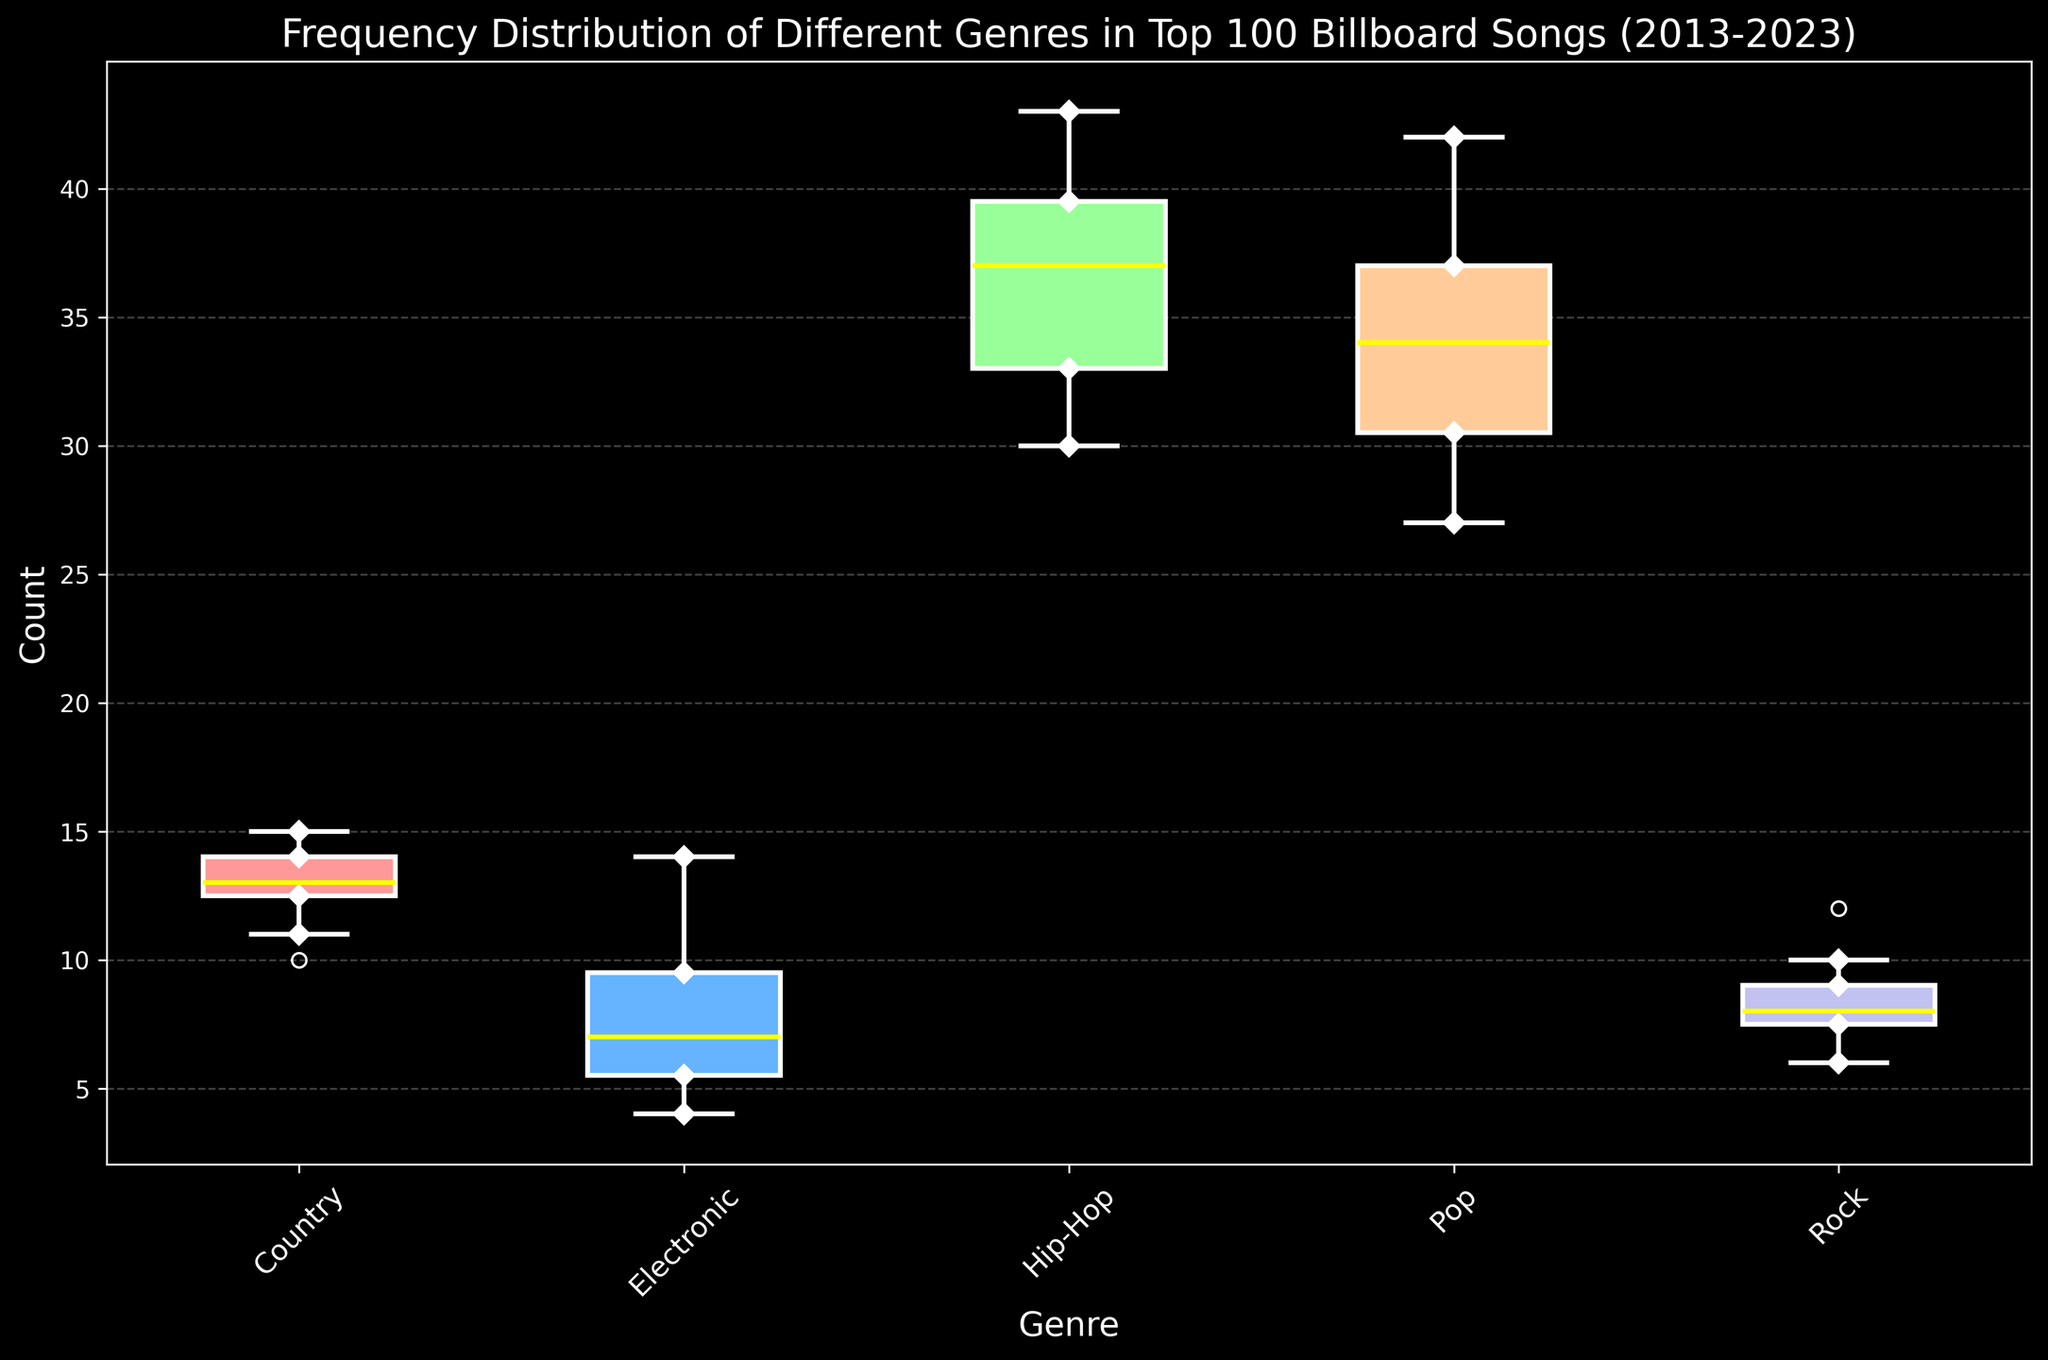What's the median count for Pop music? From the box plot, locate the median line within the Pop genre's box. The yellow line represents the median value.
Answer: 34 Which genre has the highest maximum count? Examine the top whisker of all box plots to determine which genre has the highest value. Hip-Hop genre has the highest whiskers indicating the highest maximum count.
Answer: Hip-Hop What is the interquartile range (IQR) for Country music? The IQR is calculated as the difference between the upper quartile (Q3) and the lower quartile (Q1). From the box plot, locate these values for Country music and subtract the lower quartile from the upper quartile.
Answer: 4 How does the variability in counts for Electronic music compare to Rock music? Assess the height of the boxes and thus the range of the counts within each box plot. The box for Electronic is taller than Rock, indicating greater variability.
Answer: Greater for Electronic Which genre has the smallest range? Determine the genre with the shortest distance between its whiskers. Rock music has the smallest range, visible through the shortest whiskers.
Answer: Rock Are the counts for Hip-Hop consistently increasing over the years? Examining the height and consistency of the median line in the Hip-Hop box plot over the years confirms a consistent increase.
Answer: Yes What's the average count for Pop music? Sum all the Pop counts ([40, 38, 42, 36, 35, 34, 33, 30, 29, 31, 27]) and divide by the number of years (11). The calculations are: (40+38+42+36+35+34+33+30+29+31+27)/11 = 34.1.
Answer: 34.1 Which genre shows the most increase in variance over time? Compare the spread and length of the boxes over time among the different genres. Electronic music shows the most increase in variance, as the boxes and whiskers get wider and taller.
Answer: Electronic 